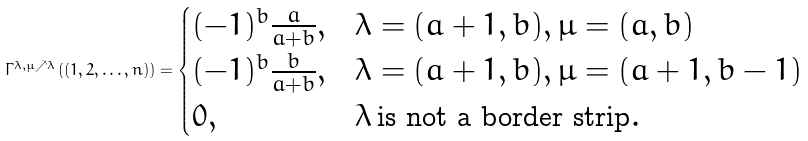<formula> <loc_0><loc_0><loc_500><loc_500>\Gamma ^ { \lambda , \mu \nearrow \lambda } \left ( ( 1 , 2 , \dots , n ) \right ) = \begin{cases} ( - 1 ) ^ { b } \frac { a } { a + b } , & \lambda = ( a + 1 , b ) , \mu = ( a , b ) \\ ( - 1 ) ^ { b } \frac { b } { a + b } , & \lambda = ( a + 1 , b ) , \mu = ( a + 1 , b - 1 ) \\ 0 , & \lambda \, \text {is not a border strip} . \end{cases}</formula> 